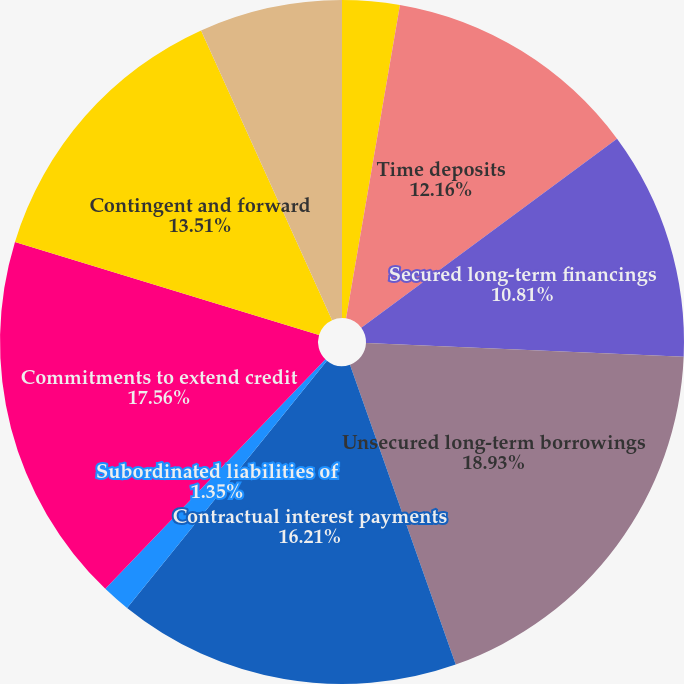<chart> <loc_0><loc_0><loc_500><loc_500><pie_chart><fcel>in millions<fcel>Time deposits<fcel>Secured long-term financings<fcel>Unsecured long-term borrowings<fcel>Contractual interest payments<fcel>Subordinated liabilities of<fcel>Commitments to extend credit<fcel>Contingent and forward<fcel>Forward starting repurchase<fcel>Letters of credit<nl><fcel>2.71%<fcel>12.16%<fcel>10.81%<fcel>18.92%<fcel>16.21%<fcel>1.35%<fcel>17.56%<fcel>13.51%<fcel>6.76%<fcel>0.0%<nl></chart> 